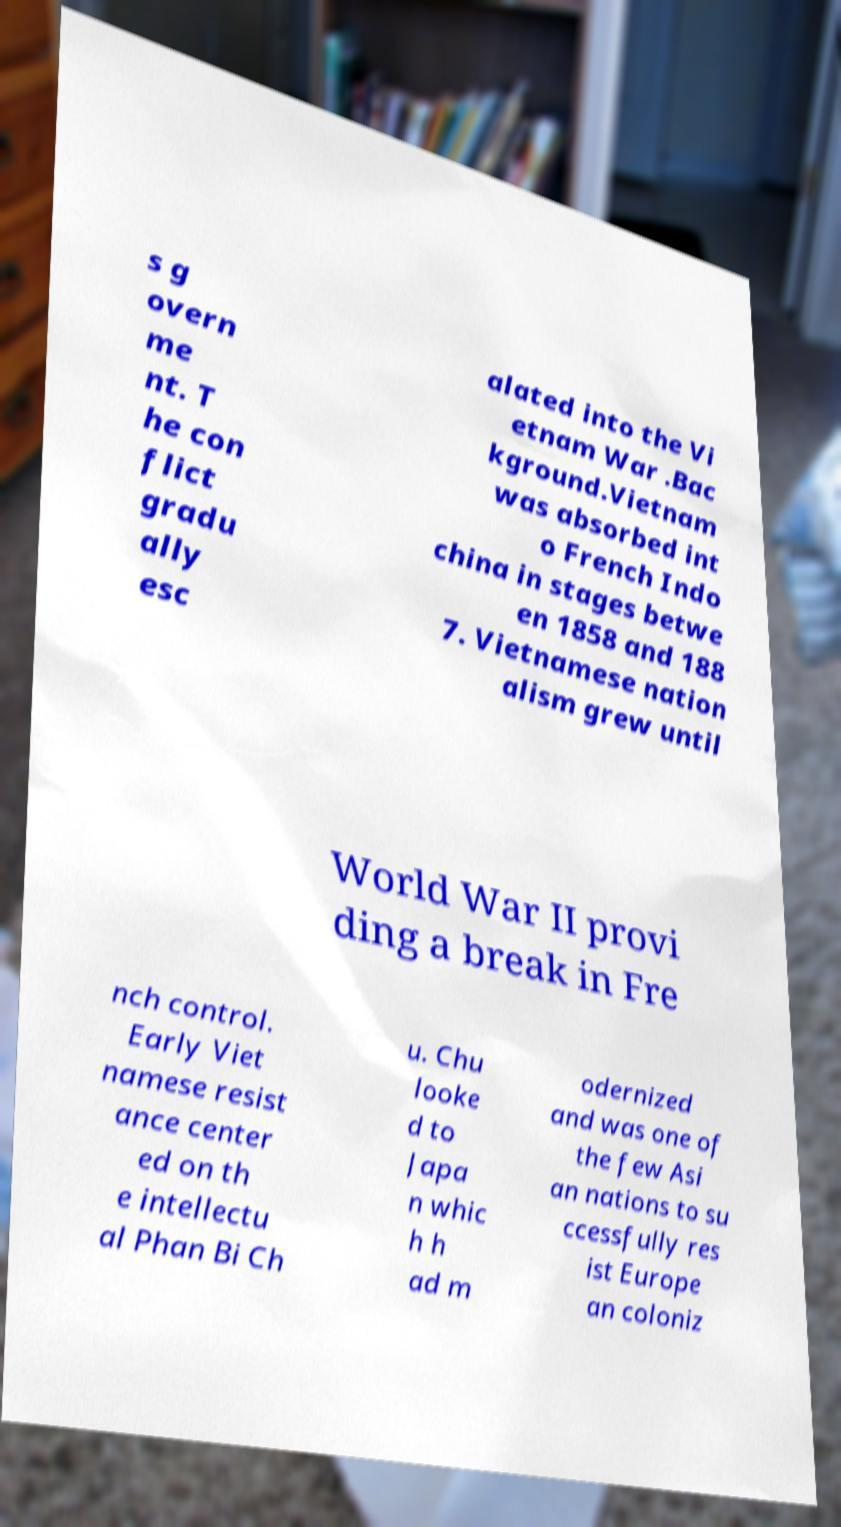Could you assist in decoding the text presented in this image and type it out clearly? s g overn me nt. T he con flict gradu ally esc alated into the Vi etnam War .Bac kground.Vietnam was absorbed int o French Indo china in stages betwe en 1858 and 188 7. Vietnamese nation alism grew until World War II provi ding a break in Fre nch control. Early Viet namese resist ance center ed on th e intellectu al Phan Bi Ch u. Chu looke d to Japa n whic h h ad m odernized and was one of the few Asi an nations to su ccessfully res ist Europe an coloniz 